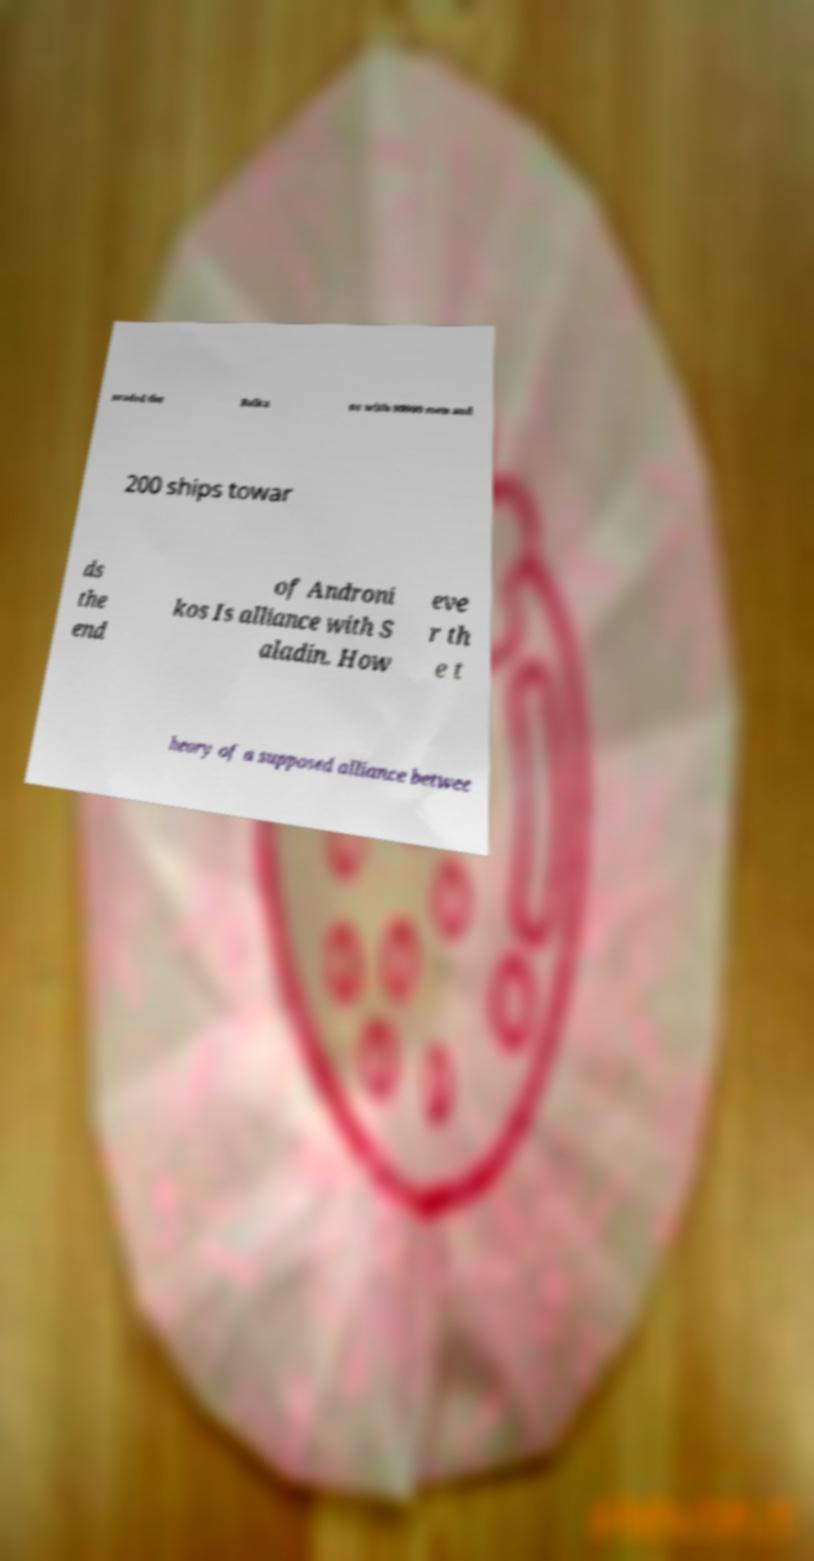What messages or text are displayed in this image? I need them in a readable, typed format. nvaded the Balka ns with 80000 men and 200 ships towar ds the end of Androni kos Is alliance with S aladin. How eve r th e t heory of a supposed alliance betwee 